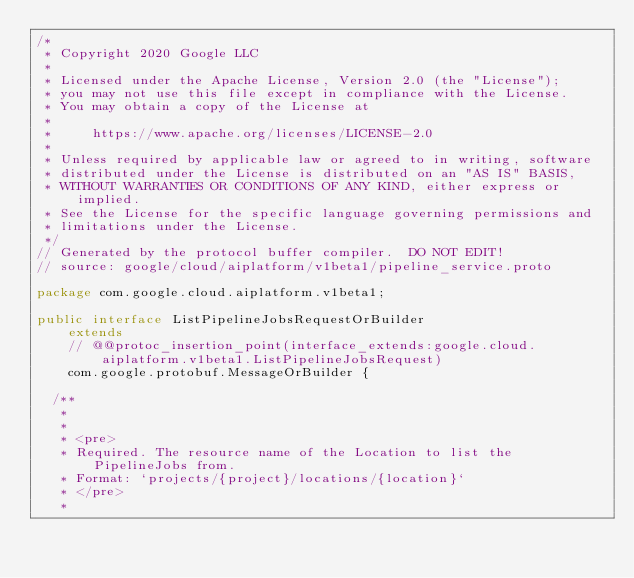<code> <loc_0><loc_0><loc_500><loc_500><_Java_>/*
 * Copyright 2020 Google LLC
 *
 * Licensed under the Apache License, Version 2.0 (the "License");
 * you may not use this file except in compliance with the License.
 * You may obtain a copy of the License at
 *
 *     https://www.apache.org/licenses/LICENSE-2.0
 *
 * Unless required by applicable law or agreed to in writing, software
 * distributed under the License is distributed on an "AS IS" BASIS,
 * WITHOUT WARRANTIES OR CONDITIONS OF ANY KIND, either express or implied.
 * See the License for the specific language governing permissions and
 * limitations under the License.
 */
// Generated by the protocol buffer compiler.  DO NOT EDIT!
// source: google/cloud/aiplatform/v1beta1/pipeline_service.proto

package com.google.cloud.aiplatform.v1beta1;

public interface ListPipelineJobsRequestOrBuilder
    extends
    // @@protoc_insertion_point(interface_extends:google.cloud.aiplatform.v1beta1.ListPipelineJobsRequest)
    com.google.protobuf.MessageOrBuilder {

  /**
   *
   *
   * <pre>
   * Required. The resource name of the Location to list the PipelineJobs from.
   * Format: `projects/{project}/locations/{location}`
   * </pre>
   *</code> 